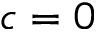<formula> <loc_0><loc_0><loc_500><loc_500>c = 0</formula> 